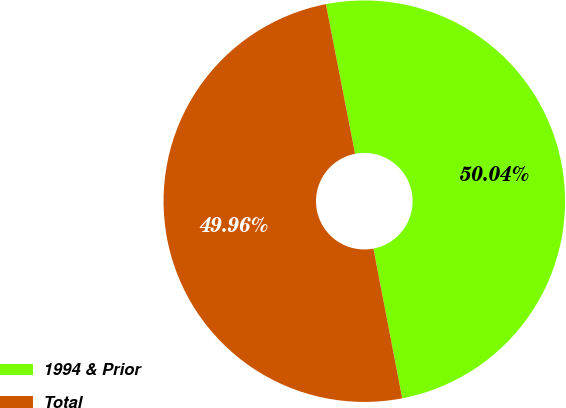<chart> <loc_0><loc_0><loc_500><loc_500><pie_chart><fcel>1994 & Prior<fcel>Total<nl><fcel>50.04%<fcel>49.96%<nl></chart> 